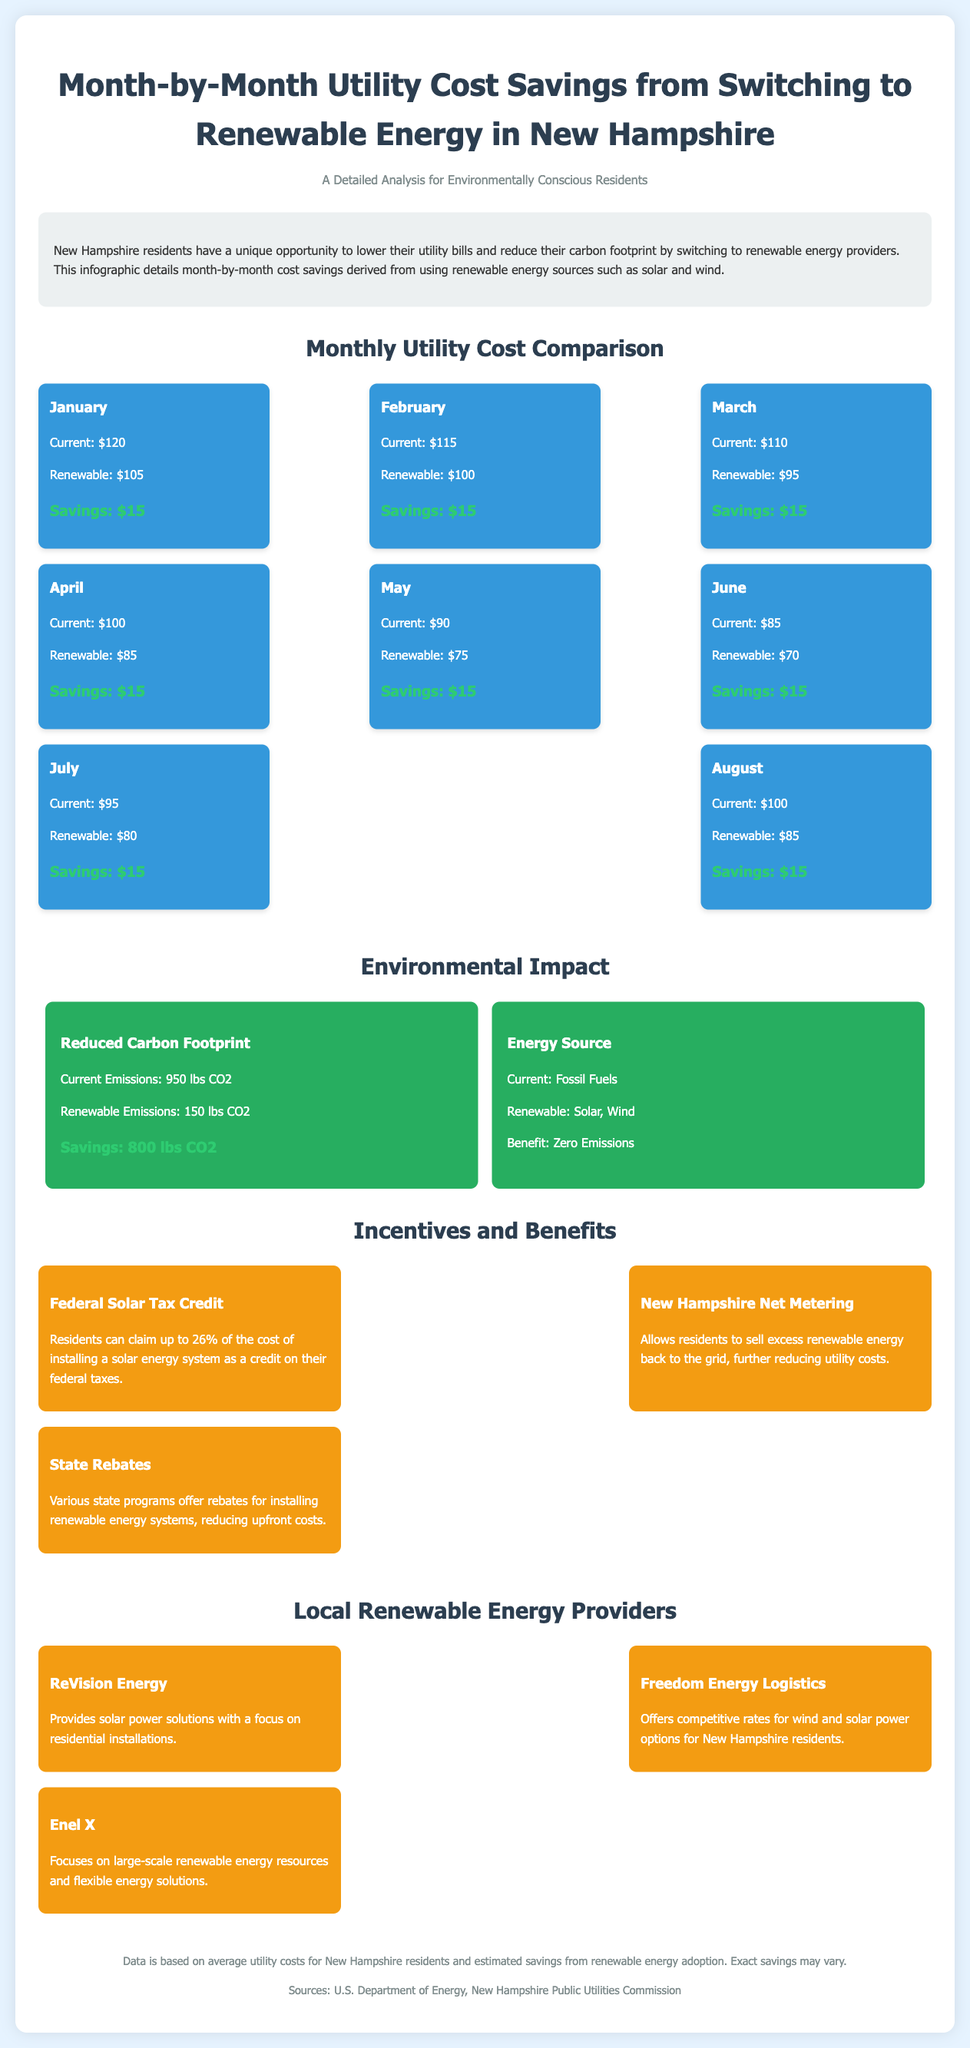What were the utility costs in February? The document states that the current utility cost was $115 and the renewable cost was $100 in February.
Answer: $115 How much can residents save each month by switching to renewable energy? The monthly savings from switching to renewable energy is consistently stated across the months in the document.
Answer: $15 What is the current emissions level using fossil fuels? The infographic shows the current emissions level when using fossil fuels, which is noted in the environmental impact section.
Answer: 950 lbs CO2 What renewable energy sources are mentioned in the document? The document details the types of renewable energy sources used, specifically in the environmental impact section.
Answer: Solar, Wind Which month showed the lowest current utility cost? The month with the lowest current utility cost can be inferred from the monthly utility cost comparison section.
Answer: May What benefit is discussed related to selling excess renewable energy? The document mentions a specific benefit associated with selling excess renewable energy in New Hampshire, noted under incentives.
Answer: Net Metering What is the monthly renewable energy cost in July? The cost for renewable energy in July is stated in the cost comparison section of the document.
Answer: $80 How much CO2 reduction is associated with switching to renewable energy? The document specifies the reduction in CO2 emissions when switching to renewable energy, which requires comparison between current and renewable emissions.
Answer: 800 lbs CO2 Which company provides solar power solutions? One of the local energy providers mentioned in the document focuses on solar power solutions for residents.
Answer: ReVision Energy 